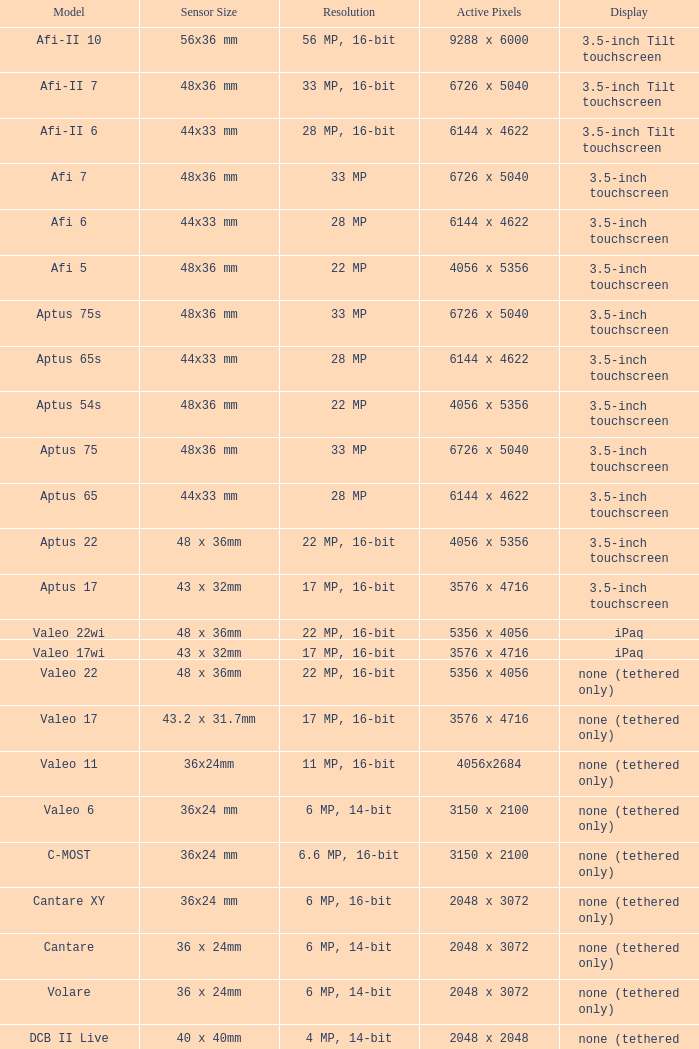What are the active pixels of the c-most model camera? 3150 x 2100. 